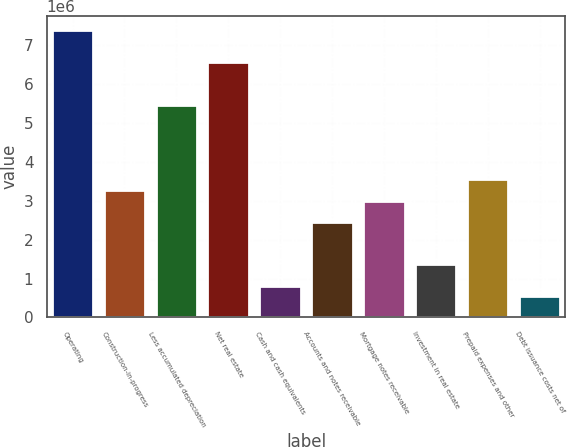Convert chart. <chart><loc_0><loc_0><loc_500><loc_500><bar_chart><fcel>Operating<fcel>Construction-in-progress<fcel>Less accumulated depreciation<fcel>Net real estate<fcel>Cash and cash equivalents<fcel>Accounts and notes receivable<fcel>Mortgage notes receivable<fcel>Investment in real estate<fcel>Prepaid expenses and other<fcel>Debt issuance costs net of<nl><fcel>7.37465e+06<fcel>3.27792e+06<fcel>5.46284e+06<fcel>6.5553e+06<fcel>819889<fcel>2.45858e+06<fcel>3.00481e+06<fcel>1.36612e+06<fcel>3.55104e+06<fcel>546774<nl></chart> 